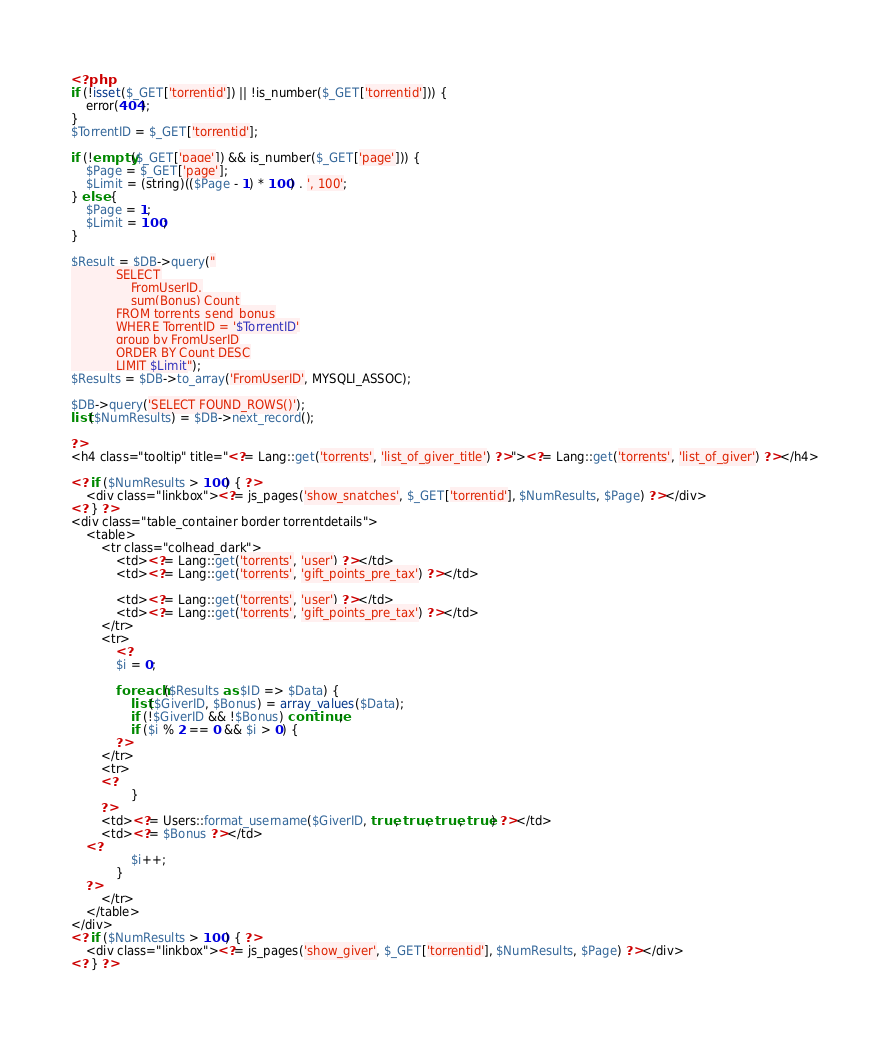<code> <loc_0><loc_0><loc_500><loc_500><_PHP_><?php
if (!isset($_GET['torrentid']) || !is_number($_GET['torrentid'])) {
    error(404);
}
$TorrentID = $_GET['torrentid'];

if (!empty($_GET['page']) && is_number($_GET['page'])) {
    $Page = $_GET['page'];
    $Limit = (string)(($Page - 1) * 100) . ', 100';
} else {
    $Page = 1;
    $Limit = 100;
}

$Result = $DB->query("
			SELECT
                FromUserID,
                sum(Bonus) Count
			FROM torrents_send_bonus
            WHERE TorrentID = '$TorrentID'
            group by FromUserID
            ORDER BY Count DESC
			LIMIT $Limit");
$Results = $DB->to_array('FromUserID', MYSQLI_ASSOC);

$DB->query('SELECT FOUND_ROWS()');
list($NumResults) = $DB->next_record();

?>
<h4 class="tooltip" title="<?= Lang::get('torrents', 'list_of_giver_title') ?>"><?= Lang::get('torrents', 'list_of_giver') ?></h4>

<? if ($NumResults > 100) { ?>
    <div class="linkbox"><?= js_pages('show_snatches', $_GET['torrentid'], $NumResults, $Page) ?></div>
<? } ?>
<div class="table_container border torrentdetails">
    <table>
        <tr class="colhead_dark">
            <td><?= Lang::get('torrents', 'user') ?></td>
            <td><?= Lang::get('torrents', 'gift_points_pre_tax') ?></td>

            <td><?= Lang::get('torrents', 'user') ?></td>
            <td><?= Lang::get('torrents', 'gift_points_pre_tax') ?></td>
        </tr>
        <tr>
            <?
            $i = 0;

            foreach ($Results as $ID => $Data) {
                list($GiverID, $Bonus) = array_values($Data);
                if (!$GiverID && !$Bonus) continue;
                if ($i % 2 == 0 && $i > 0) {
            ?>
        </tr>
        <tr>
        <?
                }
        ?>
        <td><?= Users::format_username($GiverID, true, true, true, true) ?></td>
        <td><?= $Bonus ?></td>
    <?
                $i++;
            }
    ?>
        </tr>
    </table>
</div>
<? if ($NumResults > 100) { ?>
    <div class="linkbox"><?= js_pages('show_giver', $_GET['torrentid'], $NumResults, $Page) ?></div>
<? } ?></code> 